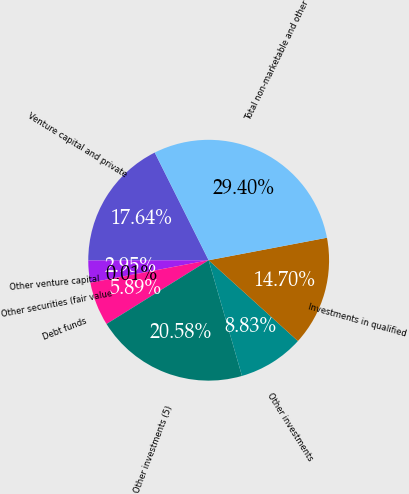Convert chart to OTSL. <chart><loc_0><loc_0><loc_500><loc_500><pie_chart><fcel>Venture capital and private<fcel>Other venture capital<fcel>Other securities (fair value<fcel>Debt funds<fcel>Other investments (5)<fcel>Other investments<fcel>Investments in qualified<fcel>Total non-marketable and other<nl><fcel>17.64%<fcel>2.95%<fcel>0.01%<fcel>5.89%<fcel>20.58%<fcel>8.83%<fcel>14.7%<fcel>29.4%<nl></chart> 